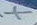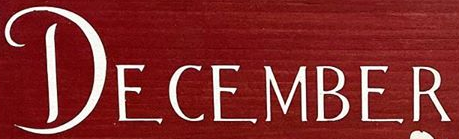What text appears in these images from left to right, separated by a semicolon? X; DECEMBER 